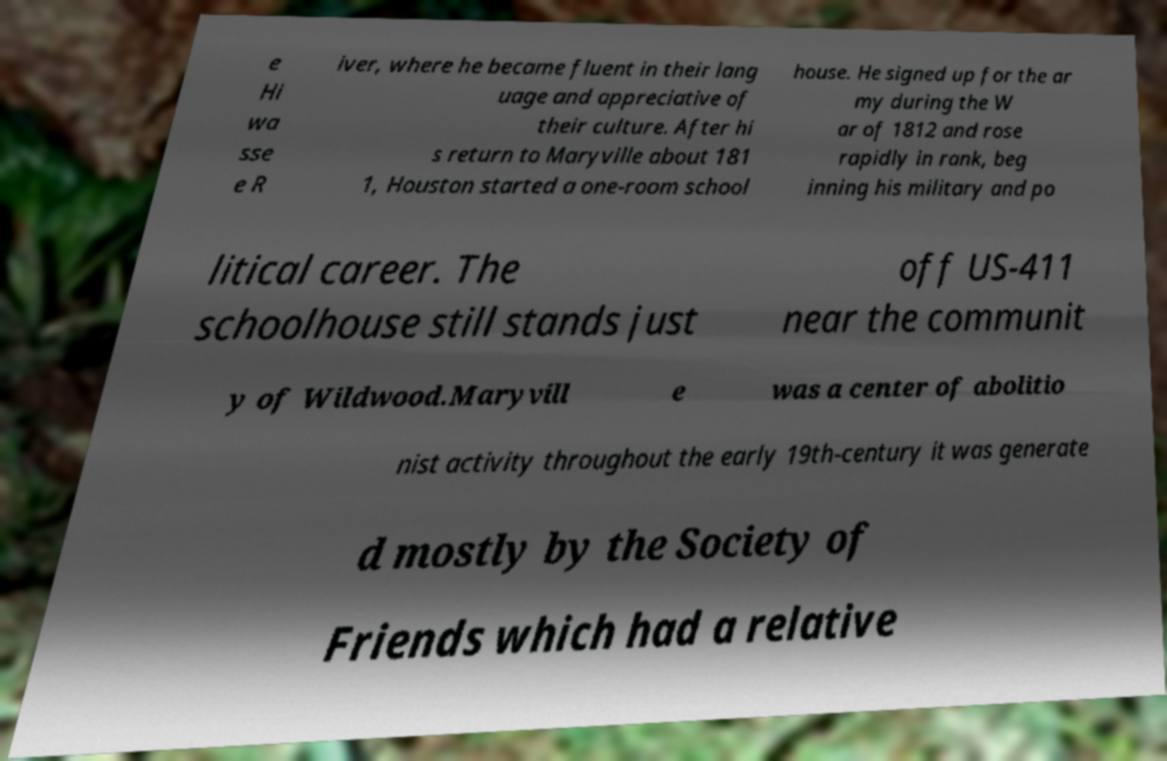Could you extract and type out the text from this image? e Hi wa sse e R iver, where he became fluent in their lang uage and appreciative of their culture. After hi s return to Maryville about 181 1, Houston started a one-room school house. He signed up for the ar my during the W ar of 1812 and rose rapidly in rank, beg inning his military and po litical career. The schoolhouse still stands just off US-411 near the communit y of Wildwood.Maryvill e was a center of abolitio nist activity throughout the early 19th-century it was generate d mostly by the Society of Friends which had a relative 